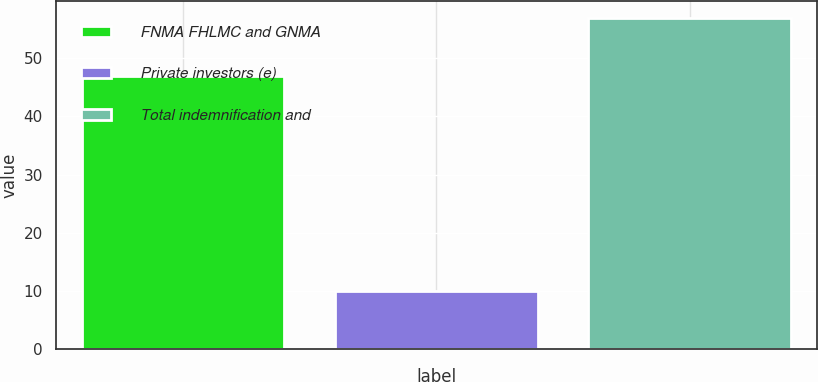Convert chart. <chart><loc_0><loc_0><loc_500><loc_500><bar_chart><fcel>FNMA FHLMC and GNMA<fcel>Private investors (e)<fcel>Total indemnification and<nl><fcel>47<fcel>10<fcel>57<nl></chart> 